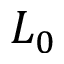<formula> <loc_0><loc_0><loc_500><loc_500>L _ { 0 }</formula> 